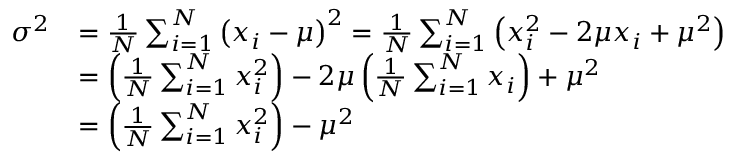Convert formula to latex. <formula><loc_0><loc_0><loc_500><loc_500>{ \begin{array} { r l } { \sigma ^ { 2 } } & { = { \frac { 1 } { N } } \sum _ { i = 1 } ^ { N } \left ( x _ { i } - \mu \right ) ^ { 2 } = { \frac { 1 } { N } } \sum _ { i = 1 } ^ { N } \left ( x _ { i } ^ { 2 } - 2 \mu x _ { i } + \mu ^ { 2 } \right ) } \\ & { = \left ( { \frac { 1 } { N } } \sum _ { i = 1 } ^ { N } x _ { i } ^ { 2 } \right ) - 2 \mu \left ( { \frac { 1 } { N } } \sum _ { i = 1 } ^ { N } x _ { i } \right ) + \mu ^ { 2 } } \\ & { = \left ( { \frac { 1 } { N } } \sum _ { i = 1 } ^ { N } x _ { i } ^ { 2 } \right ) - \mu ^ { 2 } } \end{array} }</formula> 